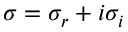<formula> <loc_0><loc_0><loc_500><loc_500>\sigma = \sigma _ { r } + i \sigma _ { i }</formula> 